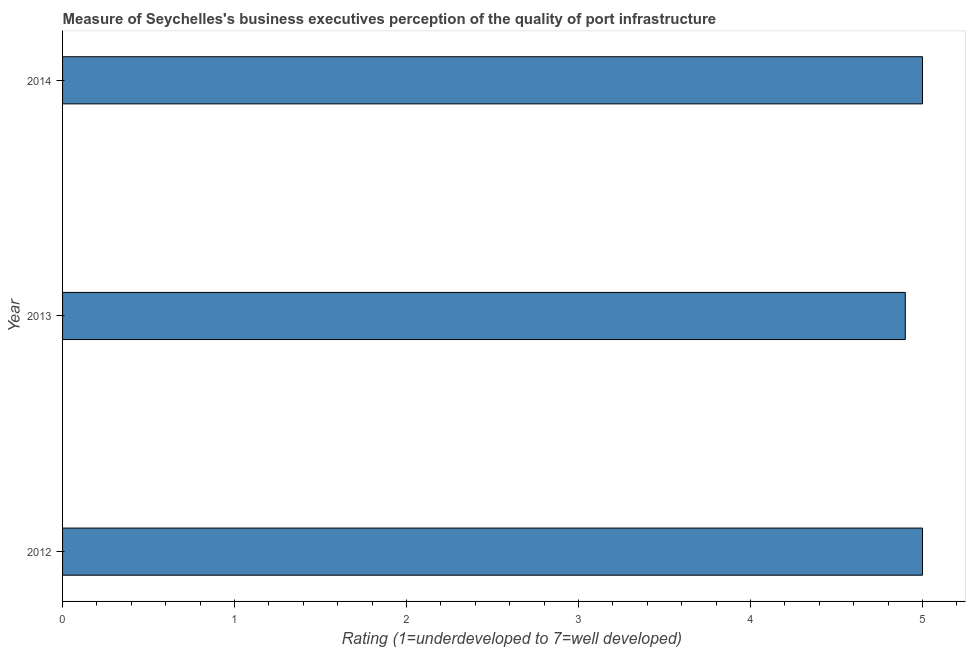Does the graph contain grids?
Keep it short and to the point. No. What is the title of the graph?
Your response must be concise. Measure of Seychelles's business executives perception of the quality of port infrastructure. What is the label or title of the X-axis?
Your response must be concise. Rating (1=underdeveloped to 7=well developed) . What is the label or title of the Y-axis?
Your answer should be very brief. Year. In which year was the rating measuring quality of port infrastructure maximum?
Provide a short and direct response. 2012. In which year was the rating measuring quality of port infrastructure minimum?
Your answer should be very brief. 2013. What is the sum of the rating measuring quality of port infrastructure?
Your answer should be compact. 14.9. What is the average rating measuring quality of port infrastructure per year?
Offer a very short reply. 4.97. In how many years, is the rating measuring quality of port infrastructure greater than 4.2 ?
Offer a very short reply. 3. Do a majority of the years between 2013 and 2012 (inclusive) have rating measuring quality of port infrastructure greater than 2.8 ?
Provide a short and direct response. No. Is the rating measuring quality of port infrastructure in 2013 less than that in 2014?
Give a very brief answer. Yes. Is the difference between the rating measuring quality of port infrastructure in 2012 and 2013 greater than the difference between any two years?
Offer a very short reply. Yes. In how many years, is the rating measuring quality of port infrastructure greater than the average rating measuring quality of port infrastructure taken over all years?
Provide a short and direct response. 2. What is the difference between two consecutive major ticks on the X-axis?
Offer a terse response. 1. Are the values on the major ticks of X-axis written in scientific E-notation?
Provide a succinct answer. No. What is the Rating (1=underdeveloped to 7=well developed)  of 2012?
Ensure brevity in your answer.  5. What is the Rating (1=underdeveloped to 7=well developed)  of 2013?
Your answer should be compact. 4.9. What is the difference between the Rating (1=underdeveloped to 7=well developed)  in 2012 and 2014?
Ensure brevity in your answer.  0. What is the difference between the Rating (1=underdeveloped to 7=well developed)  in 2013 and 2014?
Your response must be concise. -0.1. What is the ratio of the Rating (1=underdeveloped to 7=well developed)  in 2013 to that in 2014?
Give a very brief answer. 0.98. 